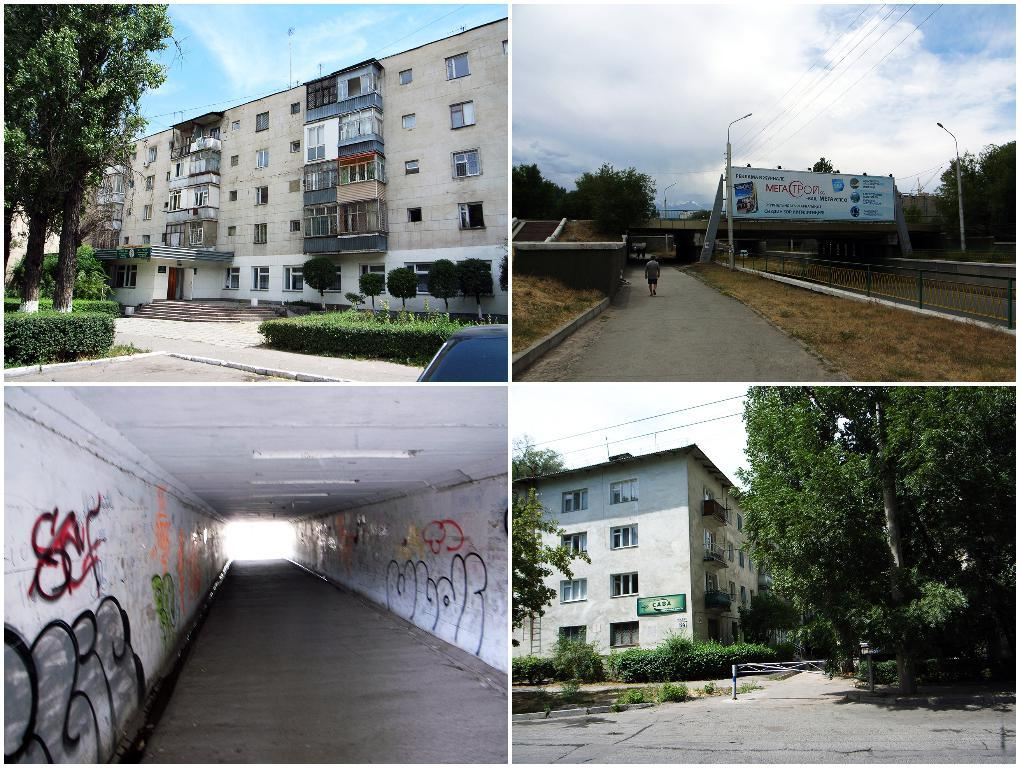What type of image is being described? The image is a collage. What type of structures can be seen in the image? There are buildings in the image. What type of natural elements can be seen in the image? There are trees in the image. What type of man-made path is visible in the image? There is a road in the image. What type of underground passage is visible in the image? There is a tunnel in the image. What type of advice does the grandmother give in the image? There is no grandmother present in the image, nor is there any indication of advice being given. What type of drawing tool is being used to create the image? The image is a collage, which is a type of artwork created by combining different images or materials, and not by using chalk. 